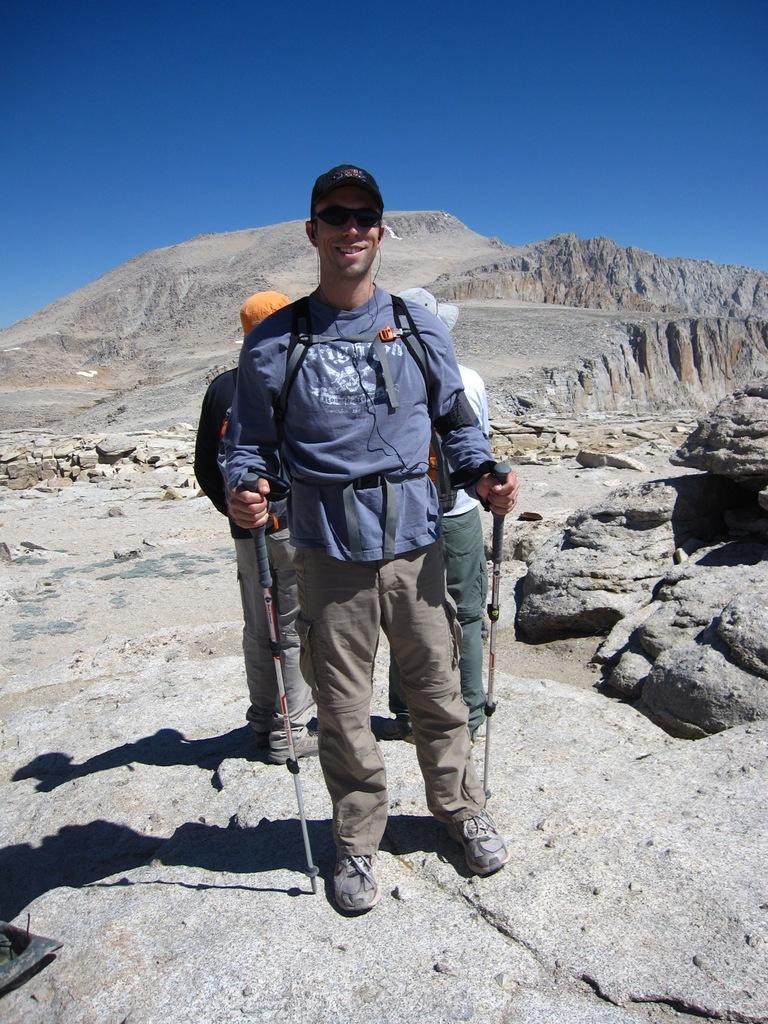Can you describe this image briefly? This is a picture of a man standing and smiling near the mountains and in back ground there is another person and sky. 